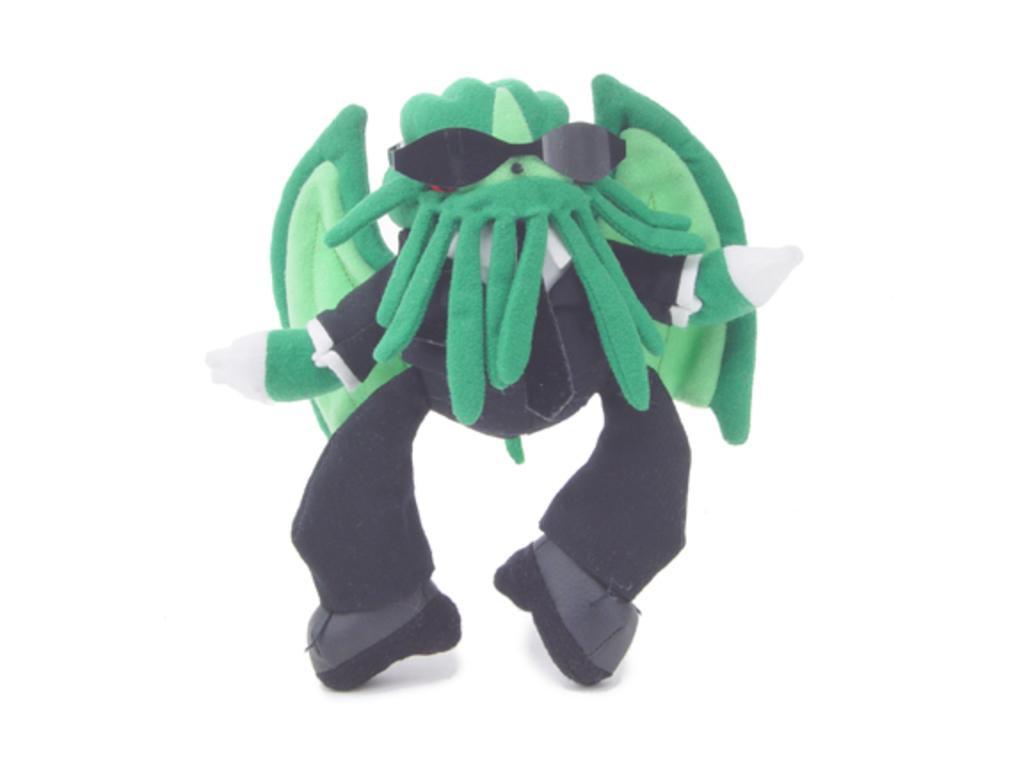Could you give a brief overview of what you see in this image? In this image there is a toy. 